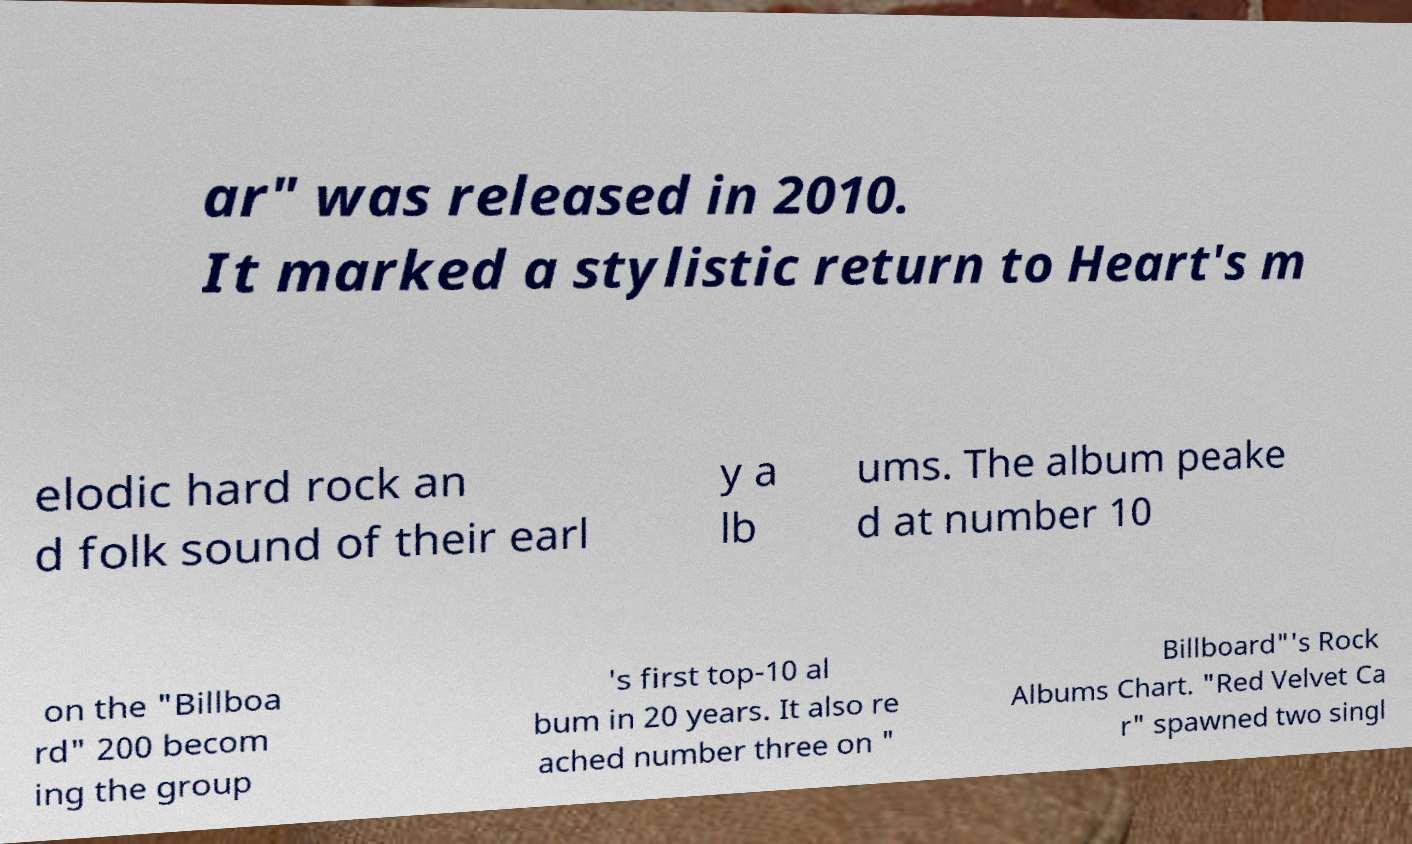Could you extract and type out the text from this image? ar" was released in 2010. It marked a stylistic return to Heart's m elodic hard rock an d folk sound of their earl y a lb ums. The album peake d at number 10 on the "Billboa rd" 200 becom ing the group 's first top-10 al bum in 20 years. It also re ached number three on " Billboard"'s Rock Albums Chart. "Red Velvet Ca r" spawned two singl 